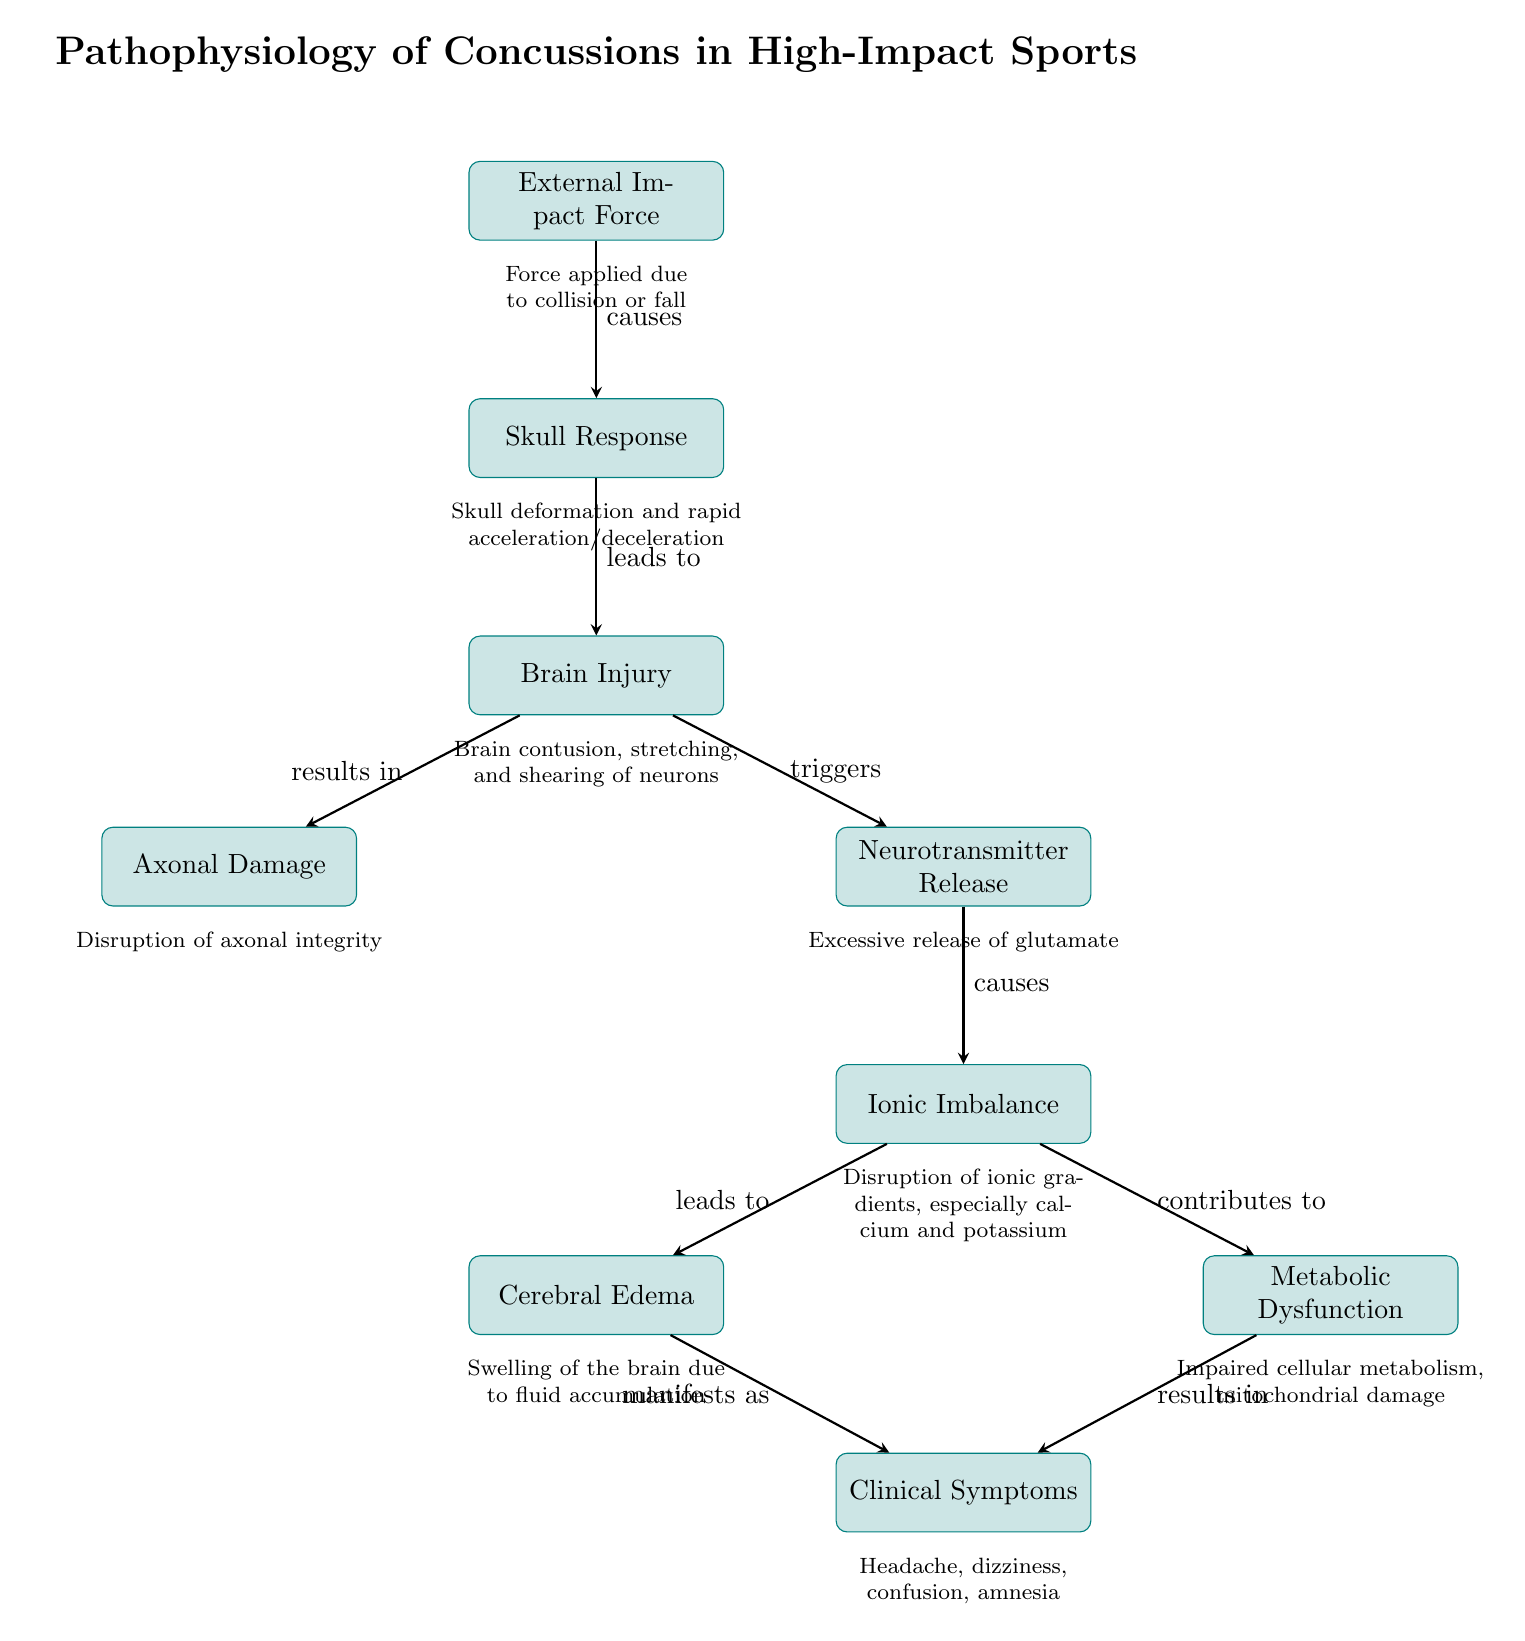What initiates the cascade of events in the diagram? The first node, "External Impact Force," indicates that the cascade begins with an external force impacting the skull. This is the trigger for all subsequent events.
Answer: External Impact Force How many main processes are illustrated in the diagram? By counting the rectangular nodes labeled as processes, we identify a total of seven main processes: External Impact Force, Skull Response, Brain Injury, Axonal Damage, Neurotransmitter Release, Ionic Imbalance, and Clinical Symptoms.
Answer: Seven What is the relationship between Brain Injury and Axonal Damage? Examining the arrows in the diagram, we see that "Brain Injury" directly results in "Axonal Damage," as indicated by the arrow pointing from Brain Injury to Axonal Damage with the label "results in."
Answer: results in What is the last process leading to clinical symptoms in the cascade? Following the diagram from left to right, we see that both "Cerebral Edema" and "Metabolic Dysfunction" lead to "Clinical Symptoms," meaning they contribute to the symptoms experienced. The final arrow pointing to Clinical Symptoms represents the culmination of the processes depicted.
Answer: Clinical Symptoms Which process describes the excessive release of a neurotransmitter? In the diagram, "Neurotransmitter Release" specifically outlines the excessive release of glutamate following the "Brain Injury" event. This step is crucial in the pathophysiological process of concussions.
Answer: Neurotransmitter Release 